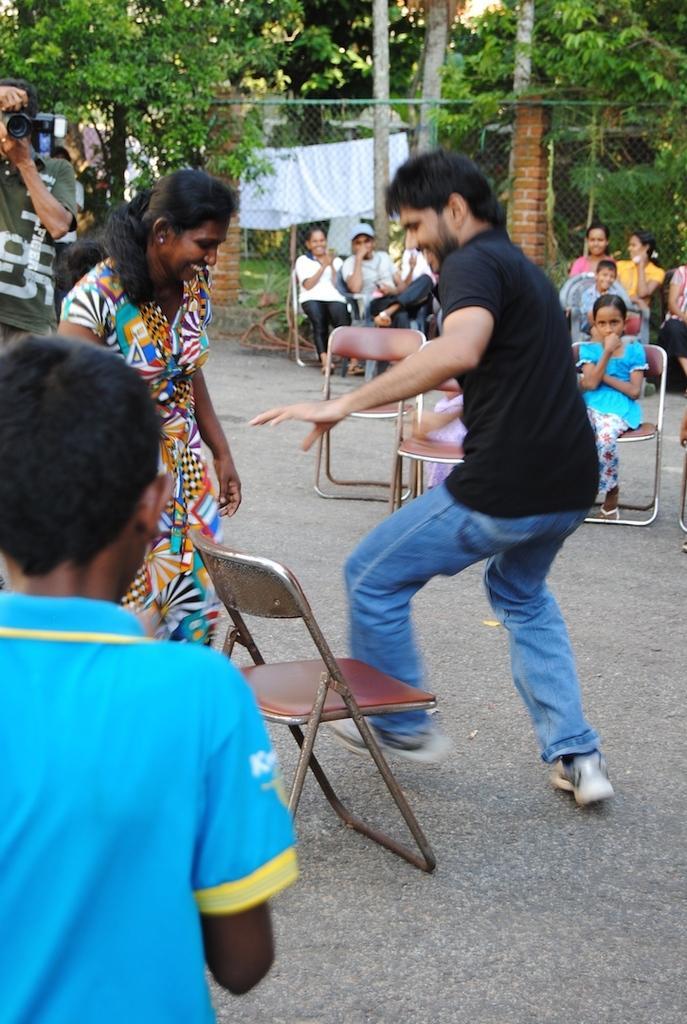Can you describe this image briefly? Two people are playing musical chair. And in the back of the lady a person is holding a camera. And a boy wearing a blue shirt is watching this. In the background some people are sitting and watching this. There are some trees in the background. Two pillars are there made of bricks. Some clothes are kept on the rope in the background. 